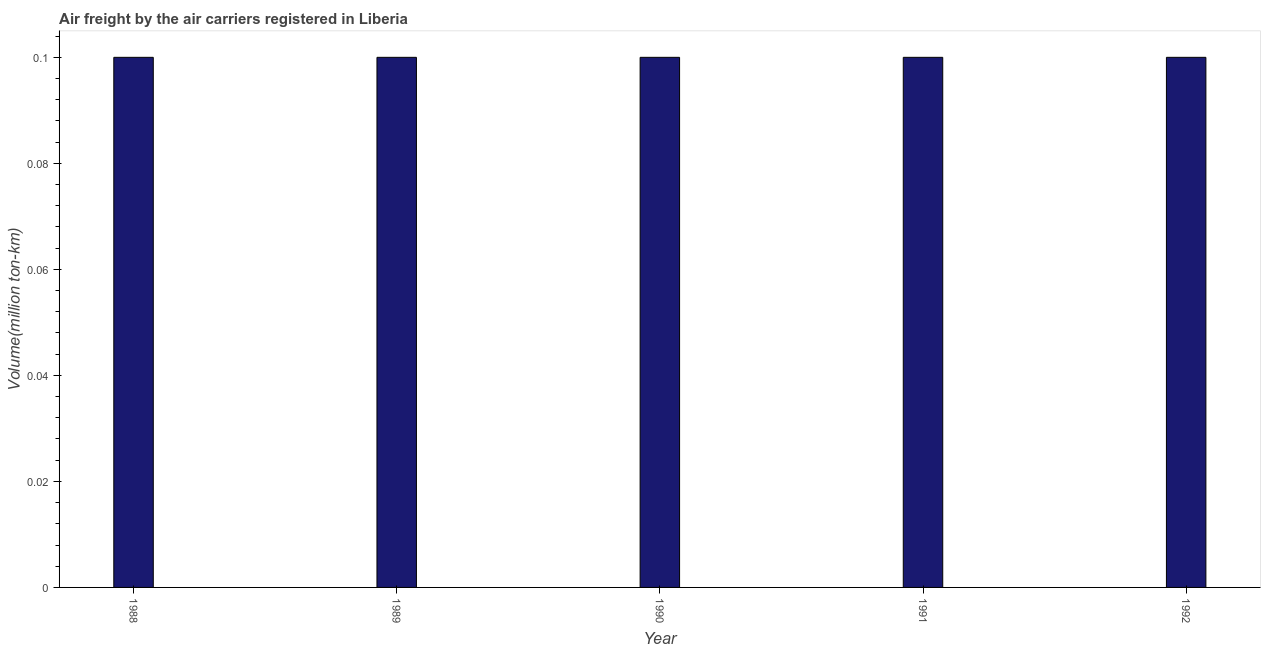Does the graph contain any zero values?
Give a very brief answer. No. Does the graph contain grids?
Your answer should be very brief. No. What is the title of the graph?
Your answer should be compact. Air freight by the air carriers registered in Liberia. What is the label or title of the Y-axis?
Your answer should be compact. Volume(million ton-km). What is the air freight in 1990?
Offer a terse response. 0.1. Across all years, what is the maximum air freight?
Provide a short and direct response. 0.1. Across all years, what is the minimum air freight?
Your answer should be very brief. 0.1. In which year was the air freight maximum?
Your answer should be very brief. 1988. What is the sum of the air freight?
Ensure brevity in your answer.  0.5. What is the difference between the air freight in 1990 and 1992?
Make the answer very short. 0. What is the median air freight?
Keep it short and to the point. 0.1. Is the air freight in 1989 less than that in 1990?
Your answer should be compact. No. What is the difference between the highest and the second highest air freight?
Keep it short and to the point. 0. In how many years, is the air freight greater than the average air freight taken over all years?
Provide a short and direct response. 0. Are all the bars in the graph horizontal?
Provide a succinct answer. No. What is the difference between two consecutive major ticks on the Y-axis?
Your answer should be compact. 0.02. What is the Volume(million ton-km) in 1988?
Offer a very short reply. 0.1. What is the Volume(million ton-km) in 1989?
Your answer should be very brief. 0.1. What is the Volume(million ton-km) of 1990?
Give a very brief answer. 0.1. What is the Volume(million ton-km) in 1991?
Provide a succinct answer. 0.1. What is the Volume(million ton-km) of 1992?
Offer a terse response. 0.1. What is the difference between the Volume(million ton-km) in 1989 and 1991?
Your response must be concise. 0. What is the difference between the Volume(million ton-km) in 1989 and 1992?
Make the answer very short. 0. What is the difference between the Volume(million ton-km) in 1990 and 1991?
Your response must be concise. 0. What is the difference between the Volume(million ton-km) in 1990 and 1992?
Keep it short and to the point. 0. What is the ratio of the Volume(million ton-km) in 1988 to that in 1989?
Make the answer very short. 1. What is the ratio of the Volume(million ton-km) in 1988 to that in 1990?
Offer a very short reply. 1. What is the ratio of the Volume(million ton-km) in 1988 to that in 1991?
Offer a very short reply. 1. What is the ratio of the Volume(million ton-km) in 1989 to that in 1991?
Provide a short and direct response. 1. What is the ratio of the Volume(million ton-km) in 1990 to that in 1991?
Give a very brief answer. 1. 